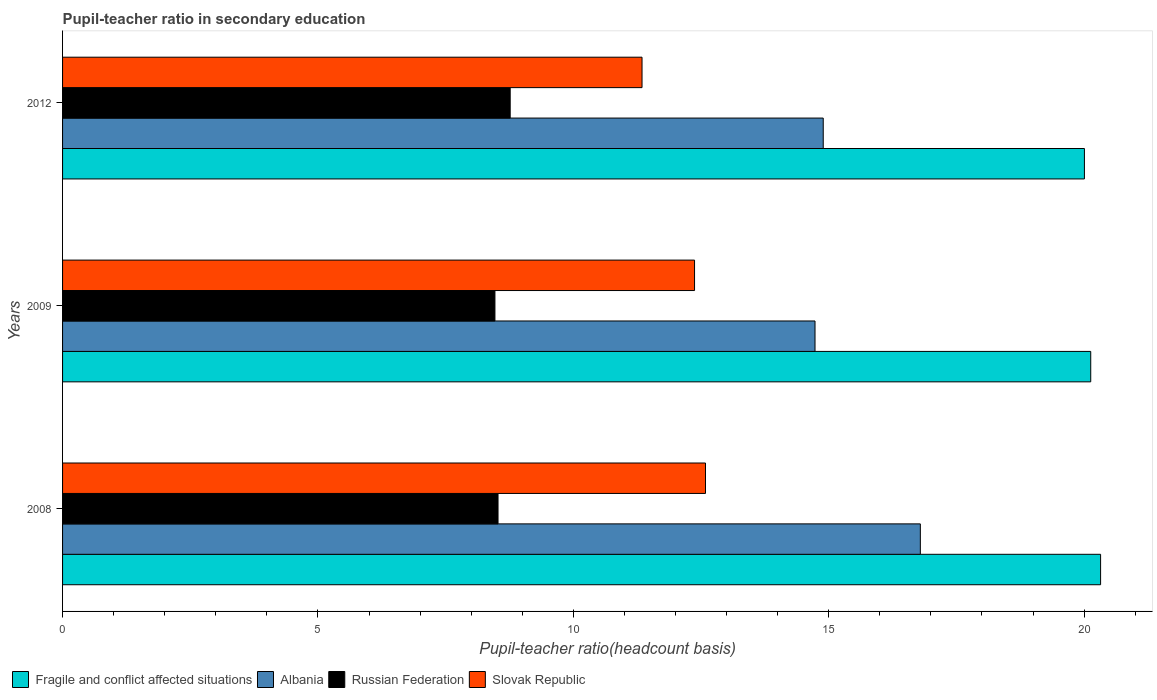How many groups of bars are there?
Provide a succinct answer. 3. Are the number of bars per tick equal to the number of legend labels?
Offer a terse response. Yes. Are the number of bars on each tick of the Y-axis equal?
Provide a short and direct response. Yes. What is the pupil-teacher ratio in secondary education in Albania in 2009?
Your response must be concise. 14.73. Across all years, what is the maximum pupil-teacher ratio in secondary education in Slovak Republic?
Ensure brevity in your answer.  12.59. Across all years, what is the minimum pupil-teacher ratio in secondary education in Slovak Republic?
Offer a very short reply. 11.35. What is the total pupil-teacher ratio in secondary education in Albania in the graph?
Provide a succinct answer. 46.42. What is the difference between the pupil-teacher ratio in secondary education in Albania in 2008 and that in 2012?
Offer a terse response. 1.9. What is the difference between the pupil-teacher ratio in secondary education in Russian Federation in 2009 and the pupil-teacher ratio in secondary education in Albania in 2008?
Your answer should be compact. -8.33. What is the average pupil-teacher ratio in secondary education in Fragile and conflict affected situations per year?
Offer a terse response. 20.15. In the year 2012, what is the difference between the pupil-teacher ratio in secondary education in Slovak Republic and pupil-teacher ratio in secondary education in Albania?
Your answer should be very brief. -3.55. In how many years, is the pupil-teacher ratio in secondary education in Fragile and conflict affected situations greater than 9 ?
Give a very brief answer. 3. What is the ratio of the pupil-teacher ratio in secondary education in Fragile and conflict affected situations in 2009 to that in 2012?
Offer a terse response. 1.01. Is the pupil-teacher ratio in secondary education in Fragile and conflict affected situations in 2008 less than that in 2012?
Ensure brevity in your answer.  No. What is the difference between the highest and the second highest pupil-teacher ratio in secondary education in Albania?
Make the answer very short. 1.9. What is the difference between the highest and the lowest pupil-teacher ratio in secondary education in Russian Federation?
Your response must be concise. 0.3. What does the 1st bar from the top in 2008 represents?
Offer a terse response. Slovak Republic. What does the 4th bar from the bottom in 2009 represents?
Your response must be concise. Slovak Republic. Is it the case that in every year, the sum of the pupil-teacher ratio in secondary education in Slovak Republic and pupil-teacher ratio in secondary education in Albania is greater than the pupil-teacher ratio in secondary education in Fragile and conflict affected situations?
Provide a succinct answer. Yes. How many bars are there?
Make the answer very short. 12. Are all the bars in the graph horizontal?
Make the answer very short. Yes. How many years are there in the graph?
Give a very brief answer. 3. Does the graph contain any zero values?
Your response must be concise. No. Does the graph contain grids?
Give a very brief answer. No. How many legend labels are there?
Offer a terse response. 4. What is the title of the graph?
Your response must be concise. Pupil-teacher ratio in secondary education. Does "Sub-Saharan Africa (all income levels)" appear as one of the legend labels in the graph?
Offer a very short reply. No. What is the label or title of the X-axis?
Offer a terse response. Pupil-teacher ratio(headcount basis). What is the Pupil-teacher ratio(headcount basis) of Fragile and conflict affected situations in 2008?
Offer a very short reply. 20.32. What is the Pupil-teacher ratio(headcount basis) of Albania in 2008?
Offer a very short reply. 16.79. What is the Pupil-teacher ratio(headcount basis) in Russian Federation in 2008?
Ensure brevity in your answer.  8.53. What is the Pupil-teacher ratio(headcount basis) of Slovak Republic in 2008?
Offer a very short reply. 12.59. What is the Pupil-teacher ratio(headcount basis) of Fragile and conflict affected situations in 2009?
Offer a terse response. 20.13. What is the Pupil-teacher ratio(headcount basis) in Albania in 2009?
Your response must be concise. 14.73. What is the Pupil-teacher ratio(headcount basis) in Russian Federation in 2009?
Keep it short and to the point. 8.47. What is the Pupil-teacher ratio(headcount basis) of Slovak Republic in 2009?
Ensure brevity in your answer.  12.37. What is the Pupil-teacher ratio(headcount basis) of Fragile and conflict affected situations in 2012?
Ensure brevity in your answer.  20.01. What is the Pupil-teacher ratio(headcount basis) in Albania in 2012?
Provide a succinct answer. 14.89. What is the Pupil-teacher ratio(headcount basis) of Russian Federation in 2012?
Provide a short and direct response. 8.76. What is the Pupil-teacher ratio(headcount basis) of Slovak Republic in 2012?
Make the answer very short. 11.35. Across all years, what is the maximum Pupil-teacher ratio(headcount basis) of Fragile and conflict affected situations?
Ensure brevity in your answer.  20.32. Across all years, what is the maximum Pupil-teacher ratio(headcount basis) of Albania?
Make the answer very short. 16.79. Across all years, what is the maximum Pupil-teacher ratio(headcount basis) in Russian Federation?
Your answer should be very brief. 8.76. Across all years, what is the maximum Pupil-teacher ratio(headcount basis) in Slovak Republic?
Make the answer very short. 12.59. Across all years, what is the minimum Pupil-teacher ratio(headcount basis) of Fragile and conflict affected situations?
Provide a succinct answer. 20.01. Across all years, what is the minimum Pupil-teacher ratio(headcount basis) of Albania?
Provide a succinct answer. 14.73. Across all years, what is the minimum Pupil-teacher ratio(headcount basis) in Russian Federation?
Make the answer very short. 8.47. Across all years, what is the minimum Pupil-teacher ratio(headcount basis) of Slovak Republic?
Offer a terse response. 11.35. What is the total Pupil-teacher ratio(headcount basis) in Fragile and conflict affected situations in the graph?
Your answer should be very brief. 60.46. What is the total Pupil-teacher ratio(headcount basis) of Albania in the graph?
Your response must be concise. 46.42. What is the total Pupil-teacher ratio(headcount basis) in Russian Federation in the graph?
Provide a succinct answer. 25.75. What is the total Pupil-teacher ratio(headcount basis) in Slovak Republic in the graph?
Keep it short and to the point. 36.31. What is the difference between the Pupil-teacher ratio(headcount basis) of Fragile and conflict affected situations in 2008 and that in 2009?
Offer a terse response. 0.19. What is the difference between the Pupil-teacher ratio(headcount basis) of Albania in 2008 and that in 2009?
Ensure brevity in your answer.  2.06. What is the difference between the Pupil-teacher ratio(headcount basis) in Russian Federation in 2008 and that in 2009?
Your response must be concise. 0.06. What is the difference between the Pupil-teacher ratio(headcount basis) in Slovak Republic in 2008 and that in 2009?
Make the answer very short. 0.21. What is the difference between the Pupil-teacher ratio(headcount basis) of Fragile and conflict affected situations in 2008 and that in 2012?
Give a very brief answer. 0.32. What is the difference between the Pupil-teacher ratio(headcount basis) in Albania in 2008 and that in 2012?
Your answer should be compact. 1.9. What is the difference between the Pupil-teacher ratio(headcount basis) of Russian Federation in 2008 and that in 2012?
Provide a short and direct response. -0.24. What is the difference between the Pupil-teacher ratio(headcount basis) in Slovak Republic in 2008 and that in 2012?
Provide a succinct answer. 1.24. What is the difference between the Pupil-teacher ratio(headcount basis) of Fragile and conflict affected situations in 2009 and that in 2012?
Offer a very short reply. 0.12. What is the difference between the Pupil-teacher ratio(headcount basis) of Albania in 2009 and that in 2012?
Make the answer very short. -0.16. What is the difference between the Pupil-teacher ratio(headcount basis) of Russian Federation in 2009 and that in 2012?
Offer a terse response. -0.3. What is the difference between the Pupil-teacher ratio(headcount basis) of Slovak Republic in 2009 and that in 2012?
Offer a terse response. 1.03. What is the difference between the Pupil-teacher ratio(headcount basis) in Fragile and conflict affected situations in 2008 and the Pupil-teacher ratio(headcount basis) in Albania in 2009?
Provide a short and direct response. 5.59. What is the difference between the Pupil-teacher ratio(headcount basis) of Fragile and conflict affected situations in 2008 and the Pupil-teacher ratio(headcount basis) of Russian Federation in 2009?
Offer a terse response. 11.86. What is the difference between the Pupil-teacher ratio(headcount basis) of Fragile and conflict affected situations in 2008 and the Pupil-teacher ratio(headcount basis) of Slovak Republic in 2009?
Your answer should be compact. 7.95. What is the difference between the Pupil-teacher ratio(headcount basis) of Albania in 2008 and the Pupil-teacher ratio(headcount basis) of Russian Federation in 2009?
Your answer should be compact. 8.33. What is the difference between the Pupil-teacher ratio(headcount basis) in Albania in 2008 and the Pupil-teacher ratio(headcount basis) in Slovak Republic in 2009?
Provide a succinct answer. 4.42. What is the difference between the Pupil-teacher ratio(headcount basis) of Russian Federation in 2008 and the Pupil-teacher ratio(headcount basis) of Slovak Republic in 2009?
Make the answer very short. -3.85. What is the difference between the Pupil-teacher ratio(headcount basis) in Fragile and conflict affected situations in 2008 and the Pupil-teacher ratio(headcount basis) in Albania in 2012?
Ensure brevity in your answer.  5.43. What is the difference between the Pupil-teacher ratio(headcount basis) in Fragile and conflict affected situations in 2008 and the Pupil-teacher ratio(headcount basis) in Russian Federation in 2012?
Ensure brevity in your answer.  11.56. What is the difference between the Pupil-teacher ratio(headcount basis) of Fragile and conflict affected situations in 2008 and the Pupil-teacher ratio(headcount basis) of Slovak Republic in 2012?
Ensure brevity in your answer.  8.98. What is the difference between the Pupil-teacher ratio(headcount basis) in Albania in 2008 and the Pupil-teacher ratio(headcount basis) in Russian Federation in 2012?
Your answer should be compact. 8.03. What is the difference between the Pupil-teacher ratio(headcount basis) in Albania in 2008 and the Pupil-teacher ratio(headcount basis) in Slovak Republic in 2012?
Your response must be concise. 5.45. What is the difference between the Pupil-teacher ratio(headcount basis) in Russian Federation in 2008 and the Pupil-teacher ratio(headcount basis) in Slovak Republic in 2012?
Give a very brief answer. -2.82. What is the difference between the Pupil-teacher ratio(headcount basis) in Fragile and conflict affected situations in 2009 and the Pupil-teacher ratio(headcount basis) in Albania in 2012?
Keep it short and to the point. 5.24. What is the difference between the Pupil-teacher ratio(headcount basis) in Fragile and conflict affected situations in 2009 and the Pupil-teacher ratio(headcount basis) in Russian Federation in 2012?
Provide a short and direct response. 11.37. What is the difference between the Pupil-teacher ratio(headcount basis) of Fragile and conflict affected situations in 2009 and the Pupil-teacher ratio(headcount basis) of Slovak Republic in 2012?
Give a very brief answer. 8.79. What is the difference between the Pupil-teacher ratio(headcount basis) in Albania in 2009 and the Pupil-teacher ratio(headcount basis) in Russian Federation in 2012?
Ensure brevity in your answer.  5.97. What is the difference between the Pupil-teacher ratio(headcount basis) of Albania in 2009 and the Pupil-teacher ratio(headcount basis) of Slovak Republic in 2012?
Ensure brevity in your answer.  3.39. What is the difference between the Pupil-teacher ratio(headcount basis) of Russian Federation in 2009 and the Pupil-teacher ratio(headcount basis) of Slovak Republic in 2012?
Provide a short and direct response. -2.88. What is the average Pupil-teacher ratio(headcount basis) of Fragile and conflict affected situations per year?
Your answer should be compact. 20.15. What is the average Pupil-teacher ratio(headcount basis) in Albania per year?
Your answer should be very brief. 15.47. What is the average Pupil-teacher ratio(headcount basis) in Russian Federation per year?
Your answer should be compact. 8.59. What is the average Pupil-teacher ratio(headcount basis) in Slovak Republic per year?
Make the answer very short. 12.1. In the year 2008, what is the difference between the Pupil-teacher ratio(headcount basis) of Fragile and conflict affected situations and Pupil-teacher ratio(headcount basis) of Albania?
Provide a short and direct response. 3.53. In the year 2008, what is the difference between the Pupil-teacher ratio(headcount basis) of Fragile and conflict affected situations and Pupil-teacher ratio(headcount basis) of Russian Federation?
Ensure brevity in your answer.  11.8. In the year 2008, what is the difference between the Pupil-teacher ratio(headcount basis) of Fragile and conflict affected situations and Pupil-teacher ratio(headcount basis) of Slovak Republic?
Your answer should be very brief. 7.74. In the year 2008, what is the difference between the Pupil-teacher ratio(headcount basis) in Albania and Pupil-teacher ratio(headcount basis) in Russian Federation?
Ensure brevity in your answer.  8.27. In the year 2008, what is the difference between the Pupil-teacher ratio(headcount basis) of Albania and Pupil-teacher ratio(headcount basis) of Slovak Republic?
Keep it short and to the point. 4.21. In the year 2008, what is the difference between the Pupil-teacher ratio(headcount basis) of Russian Federation and Pupil-teacher ratio(headcount basis) of Slovak Republic?
Provide a succinct answer. -4.06. In the year 2009, what is the difference between the Pupil-teacher ratio(headcount basis) of Fragile and conflict affected situations and Pupil-teacher ratio(headcount basis) of Albania?
Offer a terse response. 5.4. In the year 2009, what is the difference between the Pupil-teacher ratio(headcount basis) in Fragile and conflict affected situations and Pupil-teacher ratio(headcount basis) in Russian Federation?
Provide a succinct answer. 11.66. In the year 2009, what is the difference between the Pupil-teacher ratio(headcount basis) in Fragile and conflict affected situations and Pupil-teacher ratio(headcount basis) in Slovak Republic?
Your answer should be very brief. 7.76. In the year 2009, what is the difference between the Pupil-teacher ratio(headcount basis) in Albania and Pupil-teacher ratio(headcount basis) in Russian Federation?
Offer a terse response. 6.27. In the year 2009, what is the difference between the Pupil-teacher ratio(headcount basis) in Albania and Pupil-teacher ratio(headcount basis) in Slovak Republic?
Give a very brief answer. 2.36. In the year 2009, what is the difference between the Pupil-teacher ratio(headcount basis) of Russian Federation and Pupil-teacher ratio(headcount basis) of Slovak Republic?
Your answer should be very brief. -3.91. In the year 2012, what is the difference between the Pupil-teacher ratio(headcount basis) in Fragile and conflict affected situations and Pupil-teacher ratio(headcount basis) in Albania?
Give a very brief answer. 5.11. In the year 2012, what is the difference between the Pupil-teacher ratio(headcount basis) of Fragile and conflict affected situations and Pupil-teacher ratio(headcount basis) of Russian Federation?
Ensure brevity in your answer.  11.24. In the year 2012, what is the difference between the Pupil-teacher ratio(headcount basis) in Fragile and conflict affected situations and Pupil-teacher ratio(headcount basis) in Slovak Republic?
Your answer should be compact. 8.66. In the year 2012, what is the difference between the Pupil-teacher ratio(headcount basis) of Albania and Pupil-teacher ratio(headcount basis) of Russian Federation?
Make the answer very short. 6.13. In the year 2012, what is the difference between the Pupil-teacher ratio(headcount basis) in Albania and Pupil-teacher ratio(headcount basis) in Slovak Republic?
Keep it short and to the point. 3.55. In the year 2012, what is the difference between the Pupil-teacher ratio(headcount basis) in Russian Federation and Pupil-teacher ratio(headcount basis) in Slovak Republic?
Give a very brief answer. -2.58. What is the ratio of the Pupil-teacher ratio(headcount basis) of Fragile and conflict affected situations in 2008 to that in 2009?
Your answer should be very brief. 1.01. What is the ratio of the Pupil-teacher ratio(headcount basis) of Albania in 2008 to that in 2009?
Your answer should be very brief. 1.14. What is the ratio of the Pupil-teacher ratio(headcount basis) of Russian Federation in 2008 to that in 2009?
Ensure brevity in your answer.  1.01. What is the ratio of the Pupil-teacher ratio(headcount basis) in Slovak Republic in 2008 to that in 2009?
Make the answer very short. 1.02. What is the ratio of the Pupil-teacher ratio(headcount basis) in Fragile and conflict affected situations in 2008 to that in 2012?
Provide a short and direct response. 1.02. What is the ratio of the Pupil-teacher ratio(headcount basis) in Albania in 2008 to that in 2012?
Your answer should be very brief. 1.13. What is the ratio of the Pupil-teacher ratio(headcount basis) of Russian Federation in 2008 to that in 2012?
Your response must be concise. 0.97. What is the ratio of the Pupil-teacher ratio(headcount basis) of Slovak Republic in 2008 to that in 2012?
Your response must be concise. 1.11. What is the ratio of the Pupil-teacher ratio(headcount basis) of Albania in 2009 to that in 2012?
Your answer should be very brief. 0.99. What is the ratio of the Pupil-teacher ratio(headcount basis) of Russian Federation in 2009 to that in 2012?
Your answer should be compact. 0.97. What is the ratio of the Pupil-teacher ratio(headcount basis) in Slovak Republic in 2009 to that in 2012?
Make the answer very short. 1.09. What is the difference between the highest and the second highest Pupil-teacher ratio(headcount basis) in Fragile and conflict affected situations?
Ensure brevity in your answer.  0.19. What is the difference between the highest and the second highest Pupil-teacher ratio(headcount basis) in Albania?
Your answer should be compact. 1.9. What is the difference between the highest and the second highest Pupil-teacher ratio(headcount basis) of Russian Federation?
Ensure brevity in your answer.  0.24. What is the difference between the highest and the second highest Pupil-teacher ratio(headcount basis) of Slovak Republic?
Your answer should be compact. 0.21. What is the difference between the highest and the lowest Pupil-teacher ratio(headcount basis) of Fragile and conflict affected situations?
Offer a very short reply. 0.32. What is the difference between the highest and the lowest Pupil-teacher ratio(headcount basis) of Albania?
Offer a very short reply. 2.06. What is the difference between the highest and the lowest Pupil-teacher ratio(headcount basis) in Russian Federation?
Offer a terse response. 0.3. What is the difference between the highest and the lowest Pupil-teacher ratio(headcount basis) of Slovak Republic?
Keep it short and to the point. 1.24. 